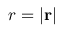<formula> <loc_0><loc_0><loc_500><loc_500>r = \left | r \right |</formula> 